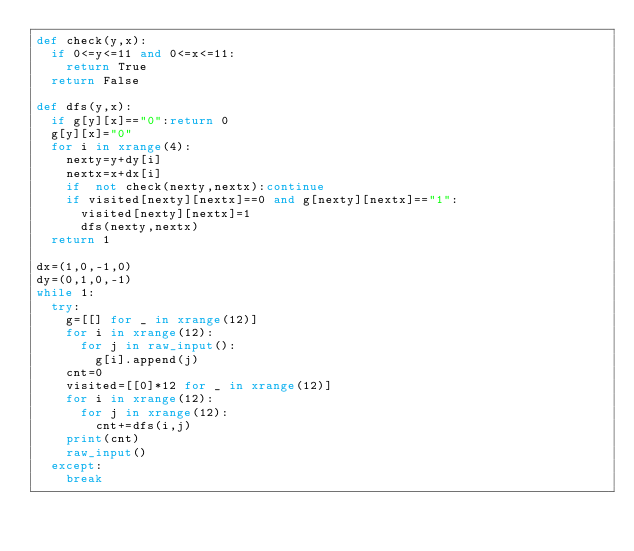<code> <loc_0><loc_0><loc_500><loc_500><_Python_>def check(y,x):
	if 0<=y<=11 and 0<=x<=11:
		return True
	return False
	
def dfs(y,x):
	if g[y][x]=="0":return 0
	g[y][x]="0"
	for i in xrange(4):
		nexty=y+dy[i]
		nextx=x+dx[i]
		if  not check(nexty,nextx):continue
		if visited[nexty][nextx]==0 and g[nexty][nextx]=="1":
			visited[nexty][nextx]=1
			dfs(nexty,nextx)
	return 1
	
dx=(1,0,-1,0)
dy=(0,1,0,-1)
while 1:
	try:
		g=[[] for _ in xrange(12)]
		for i in xrange(12):
			for j in raw_input():
				g[i].append(j)
		cnt=0
		visited=[[0]*12 for _ in xrange(12)]
		for i in xrange(12):
			for j in xrange(12):
				cnt+=dfs(i,j)
		print(cnt)
		raw_input()
	except:
		break</code> 